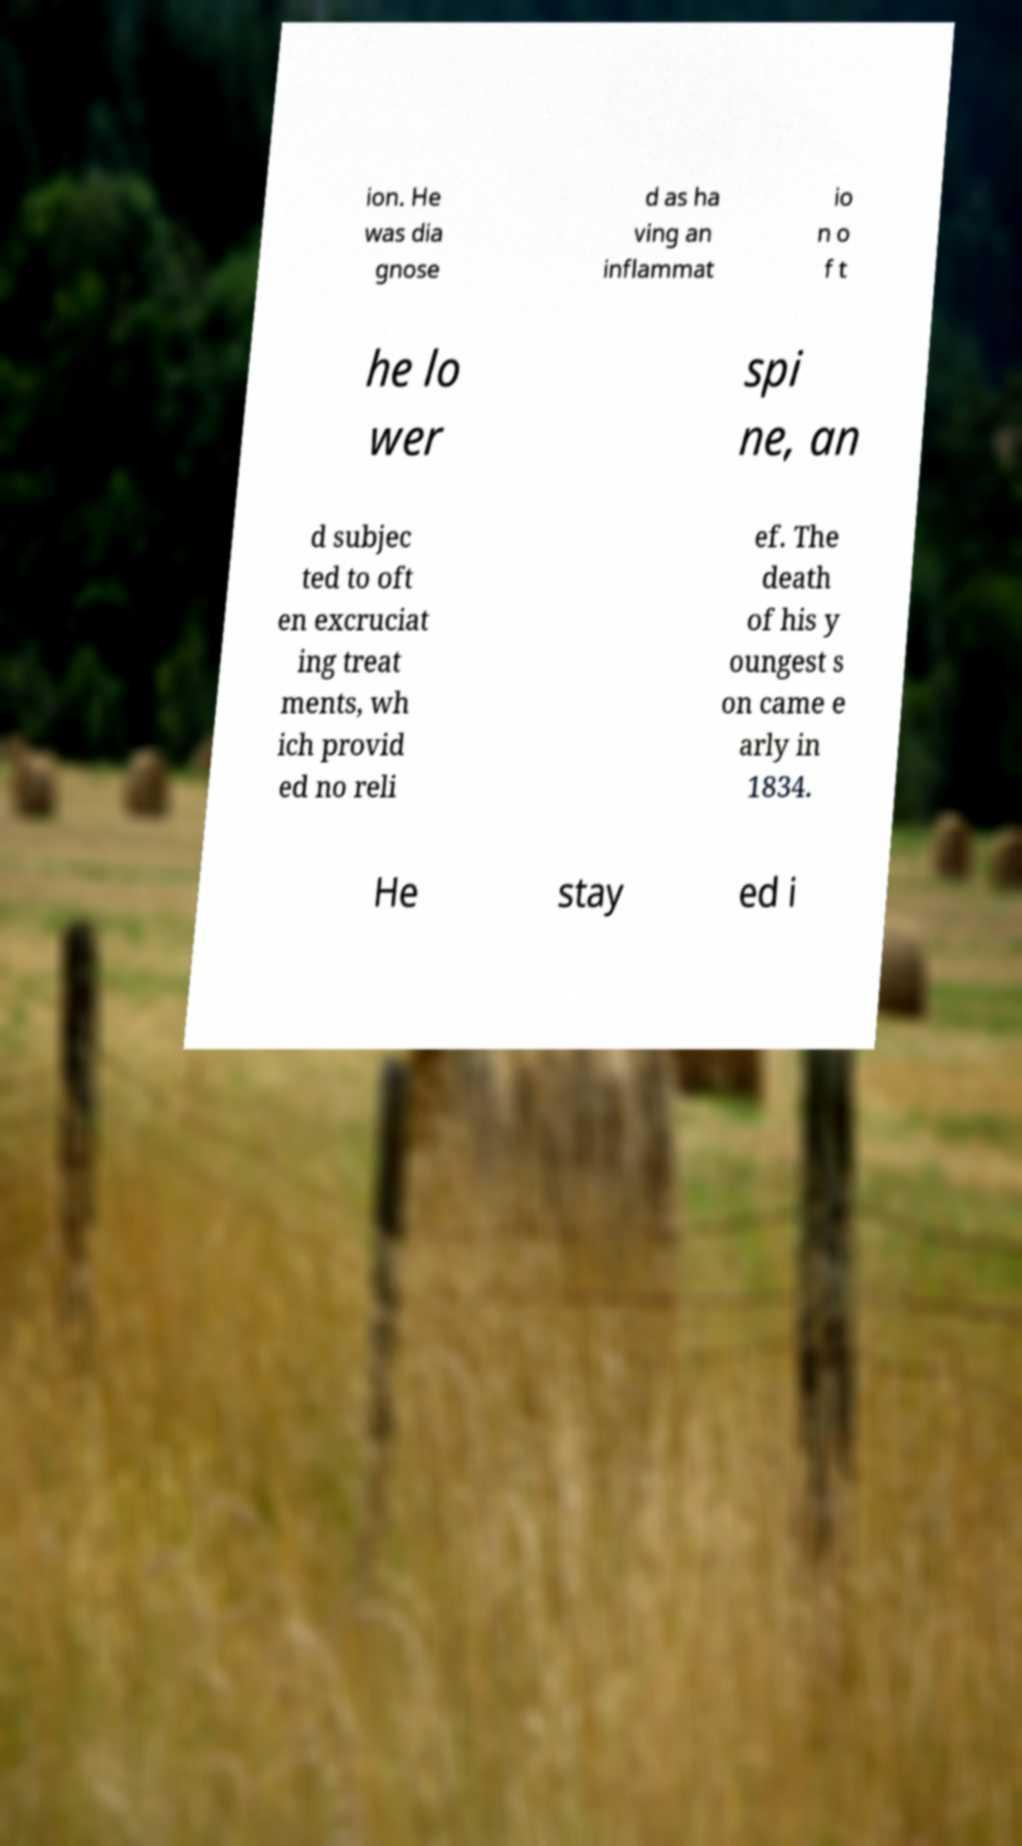Can you accurately transcribe the text from the provided image for me? ion. He was dia gnose d as ha ving an inflammat io n o f t he lo wer spi ne, an d subjec ted to oft en excruciat ing treat ments, wh ich provid ed no reli ef. The death of his y oungest s on came e arly in 1834. He stay ed i 